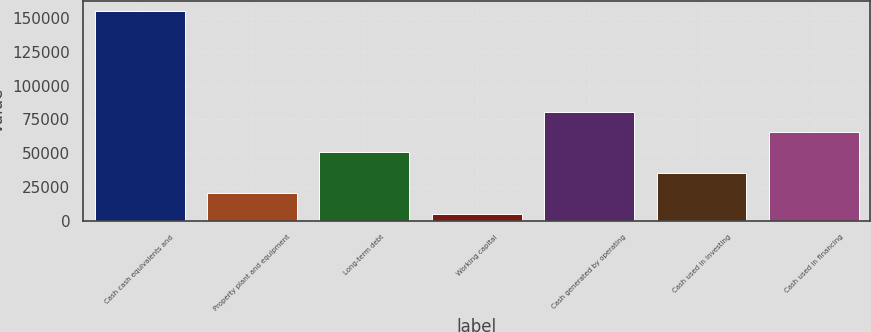Convert chart to OTSL. <chart><loc_0><loc_0><loc_500><loc_500><bar_chart><fcel>Cash cash equivalents and<fcel>Property plant and equipment<fcel>Long-term debt<fcel>Working capital<fcel>Cash generated by operating<fcel>Cash used in investing<fcel>Cash used in financing<nl><fcel>155239<fcel>20624<fcel>50655.2<fcel>5083<fcel>80686.4<fcel>35639.6<fcel>65670.8<nl></chart> 